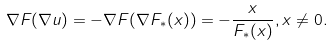Convert formula to latex. <formula><loc_0><loc_0><loc_500><loc_500>\nabla F ( \nabla u ) = - \nabla F ( \nabla F _ { * } ( x ) ) = - \frac { x } { F _ { * } ( x ) } , x \not = 0 .</formula> 